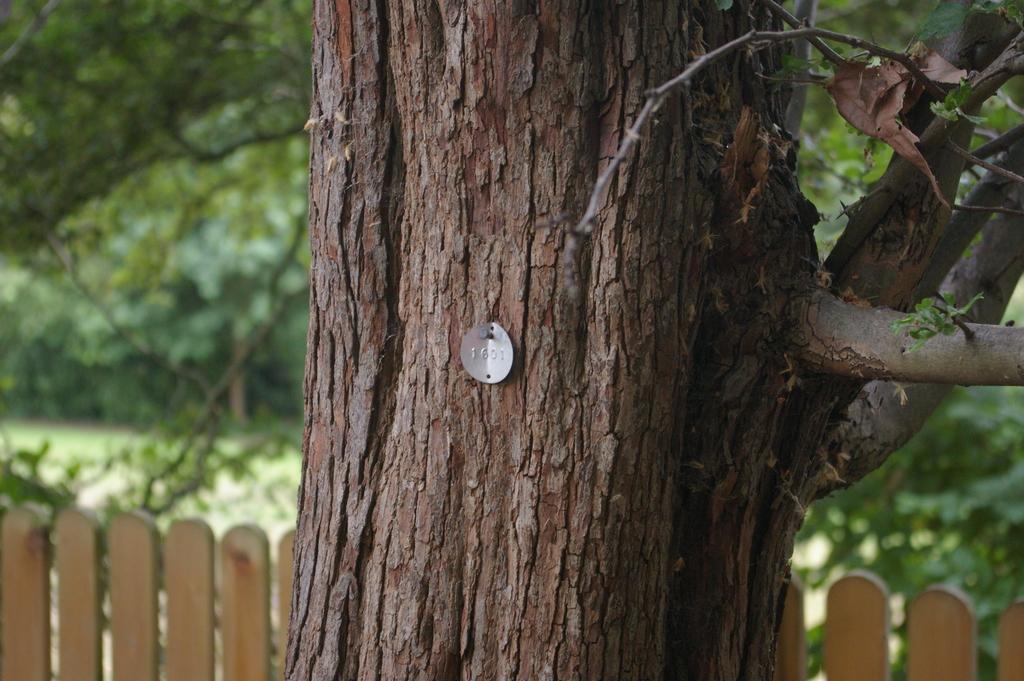Can you describe this image briefly? In this image, we can see a tree trunk with batch. In the background, we can see the blur view, fence and trees. 